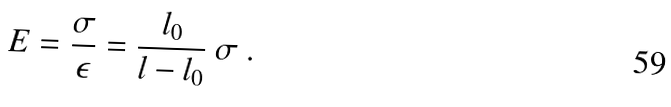<formula> <loc_0><loc_0><loc_500><loc_500>E = \frac { \sigma } { \epsilon } = \frac { l _ { 0 } } { l - l _ { 0 } } \ \sigma \ .</formula> 